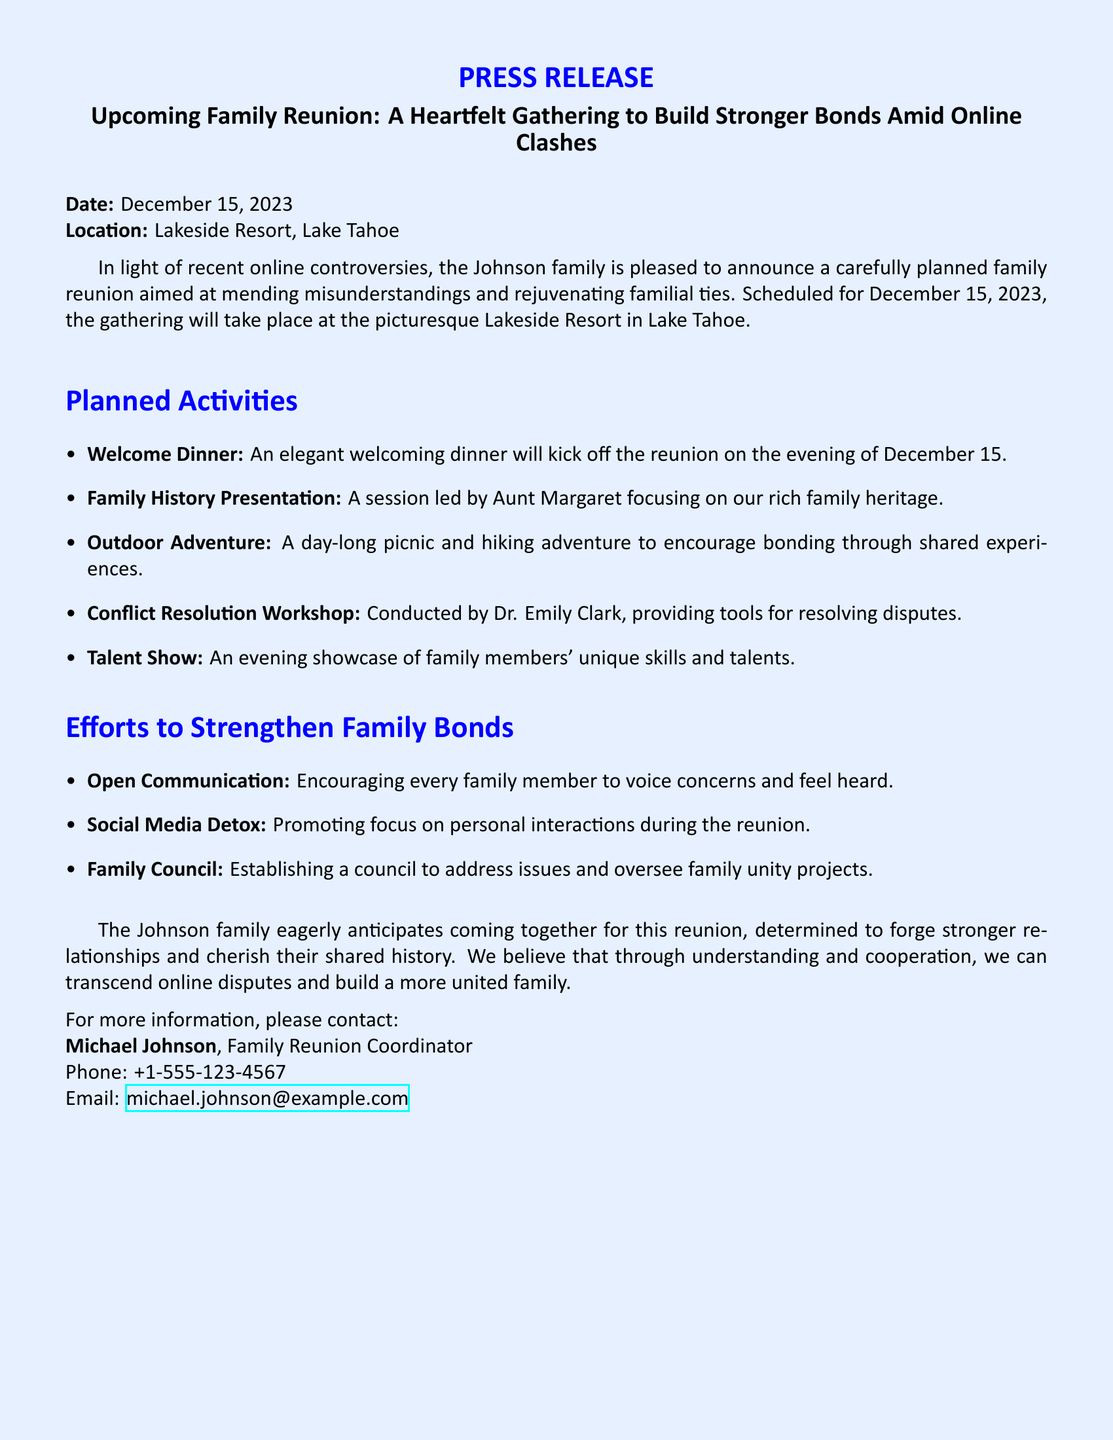what is the date of the family reunion? The date is clearly stated in the document as December 15, 2023.
Answer: December 15, 2023 where will the family reunion take place? The location of the reunion is mentioned in the press release as Lakeside Resort, Lake Tahoe.
Answer: Lakeside Resort, Lake Tahoe who is leading the Family History Presentation? The document specifies that Aunt Margaret will lead this particular session.
Answer: Aunt Margaret what is one of the planned activities at the reunion? Several activities are listed; one example is the Conflict Resolution Workshop.
Answer: Conflict Resolution Workshop what is the purpose of the Social Media Detox initiative? The text indicates that the initiative promotes focus on personal interactions during the reunion.
Answer: Focus on personal interactions how many planned activities are mentioned in the document? The document lists five planned activities overall for the reunion.
Answer: Five what organization is responsible for the family reunion? The document refers to the Johnson family as the organizers of the reunion.
Answer: Johnson family who can be contacted for more information about the reunion? The press release provides Michael Johnson as the contact person for inquiries.
Answer: Michael Johnson 